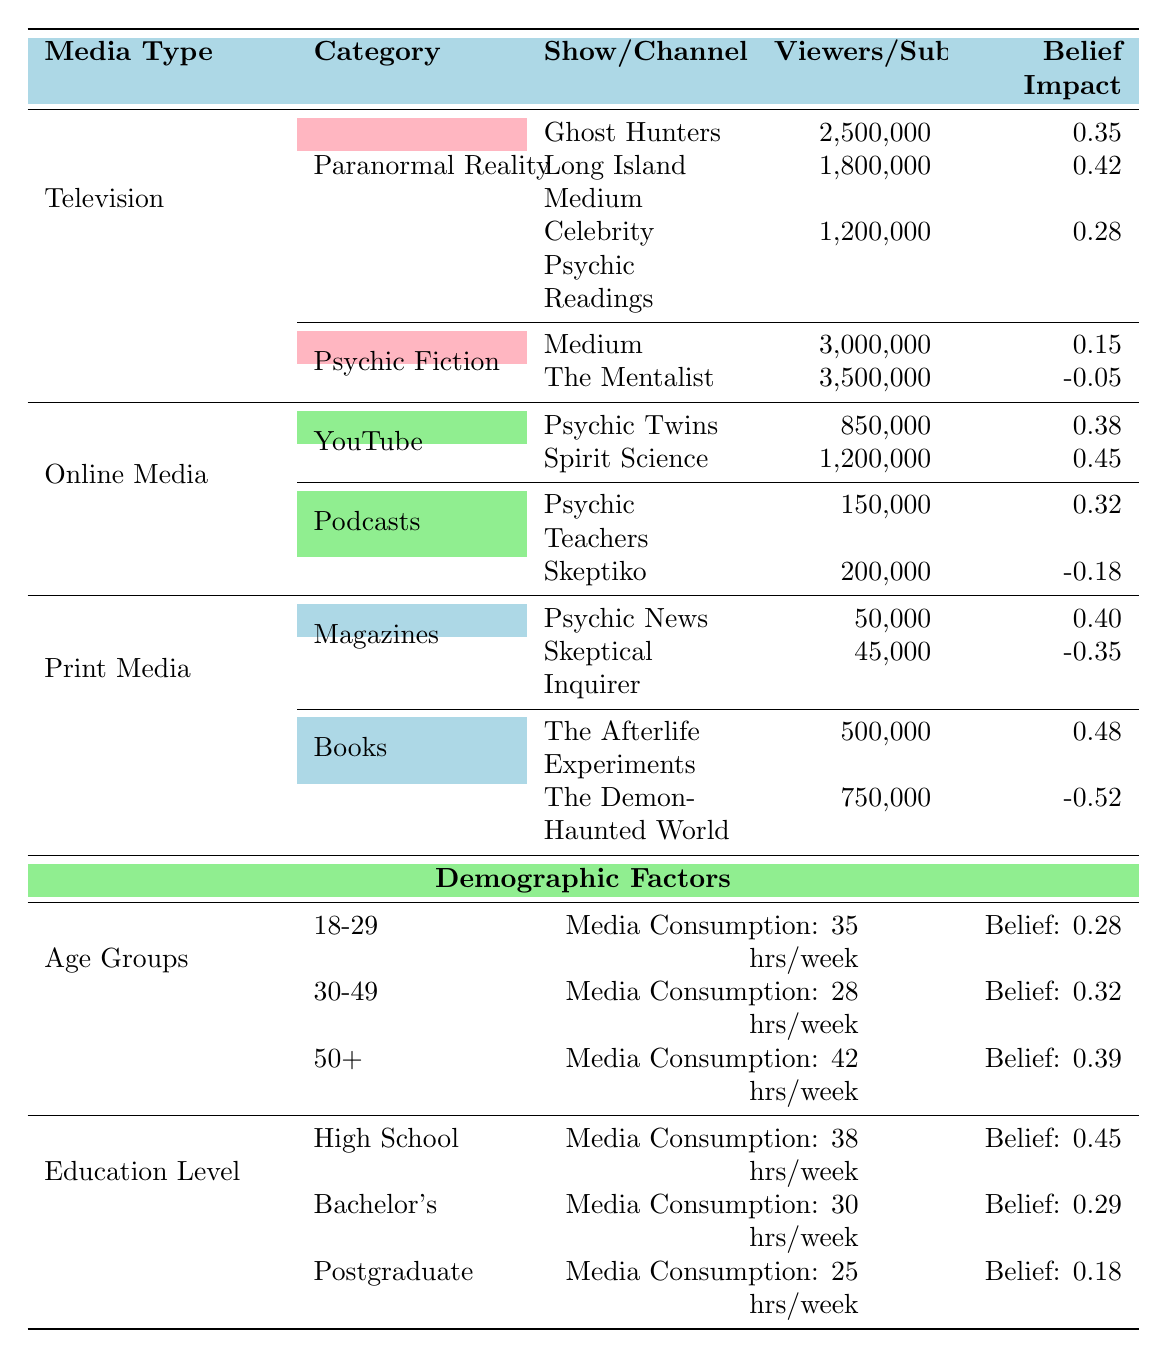What is the belief impact of the "Ghost Hunters" show? The table indicates that the belief impact for "Ghost Hunters" is 0.35.
Answer: 0.35 Which age group has the highest average belief in psychic abilities? Upon comparing the belief values for age groups, 50+ has the highest value at 0.39, which is greater than the others (0.28 and 0.32).
Answer: 50+ What is the total number of viewers for all paranormal reality shows combined? Summing the viewers: 2,500,000 (Ghost Hunters) + 1,800,000 (Long Island Medium) + 1,200,000 (Celebrity Psychic Readings) equals 5,500,000 viewers.
Answer: 5,500,000 Do more viewers subscribe to the "Psychic Twins" or "Spirit Science"? Comparing the subscriber counts, "Spirit Science" has 1,200,000 subscribers, which is greater than the "Psychic Twins" with 850,000. Thus, "Spirit Science" has more subscribers.
Answer: Spirit Science What is the difference in belief impact between "The Afterlife Experiments" and "The Demon-Haunted World"? The belief impact for "The Afterlife Experiments" is 0.48, while for "The Demon-Haunted World," it is -0.52. The difference is calculated as 0.48 - (-0.52) = 1.00.
Answer: 1.00 Is the belief impact from print media more positive than from online media? Based on the data, print media has two positive impacts (0.40, 0.48) and two negative impacts (-0.35, -0.52), where the average impact appears positive. Online media has positive impacts (0.38, 0.45) and a negative impact (-0.18), thus, overall, print media has a more positive average.
Answer: Yes Which demographic group has the highest media consumption hours per week? The 50+ age group has the highest at 42 hours/week compared to 35 for 18-29 and 28 for 30-49.
Answer: 50+ What is the average belief in psychic abilities for those with a high school education? The belief in psychic abilities for the high school education group is explicitly listed as 0.45.
Answer: 0.45 Can we conclude that watching psychic-themed fiction decreases belief in psychic abilities? The "Medium" show has a belief impact of 0.15 and "The Mentalist" has -0.05; since one is positive and the other negative, we cannot make a concrete conclusion that psychic-themed fiction in general decreases belief.
Answer: No What is the combined effect (sum) of belief impacts for all YouTube channels listed? Adding the belief impacts for the two channels gives us 0.38 + 0.45 = 0.83.
Answer: 0.83 